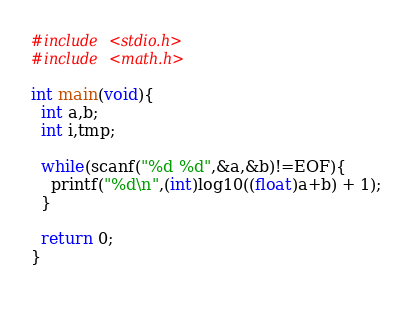Convert code to text. <code><loc_0><loc_0><loc_500><loc_500><_C_>#include <stdio.h>
#include <math.h>
 
int main(void){
  int a,b;
  int i,tmp;
   
  while(scanf("%d %d",&a,&b)!=EOF){
    printf("%d\n",(int)log10((float)a+b) + 1);
  }
   
  return 0;
}
 </code> 